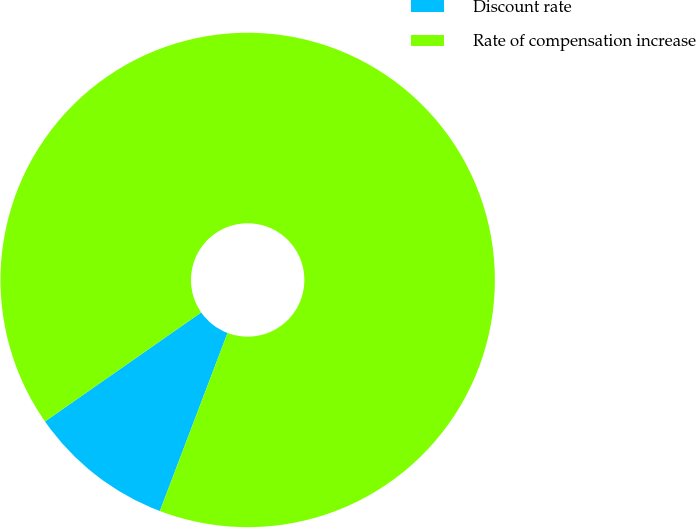Convert chart. <chart><loc_0><loc_0><loc_500><loc_500><pie_chart><fcel>Discount rate<fcel>Rate of compensation increase<nl><fcel>9.52%<fcel>90.48%<nl></chart> 